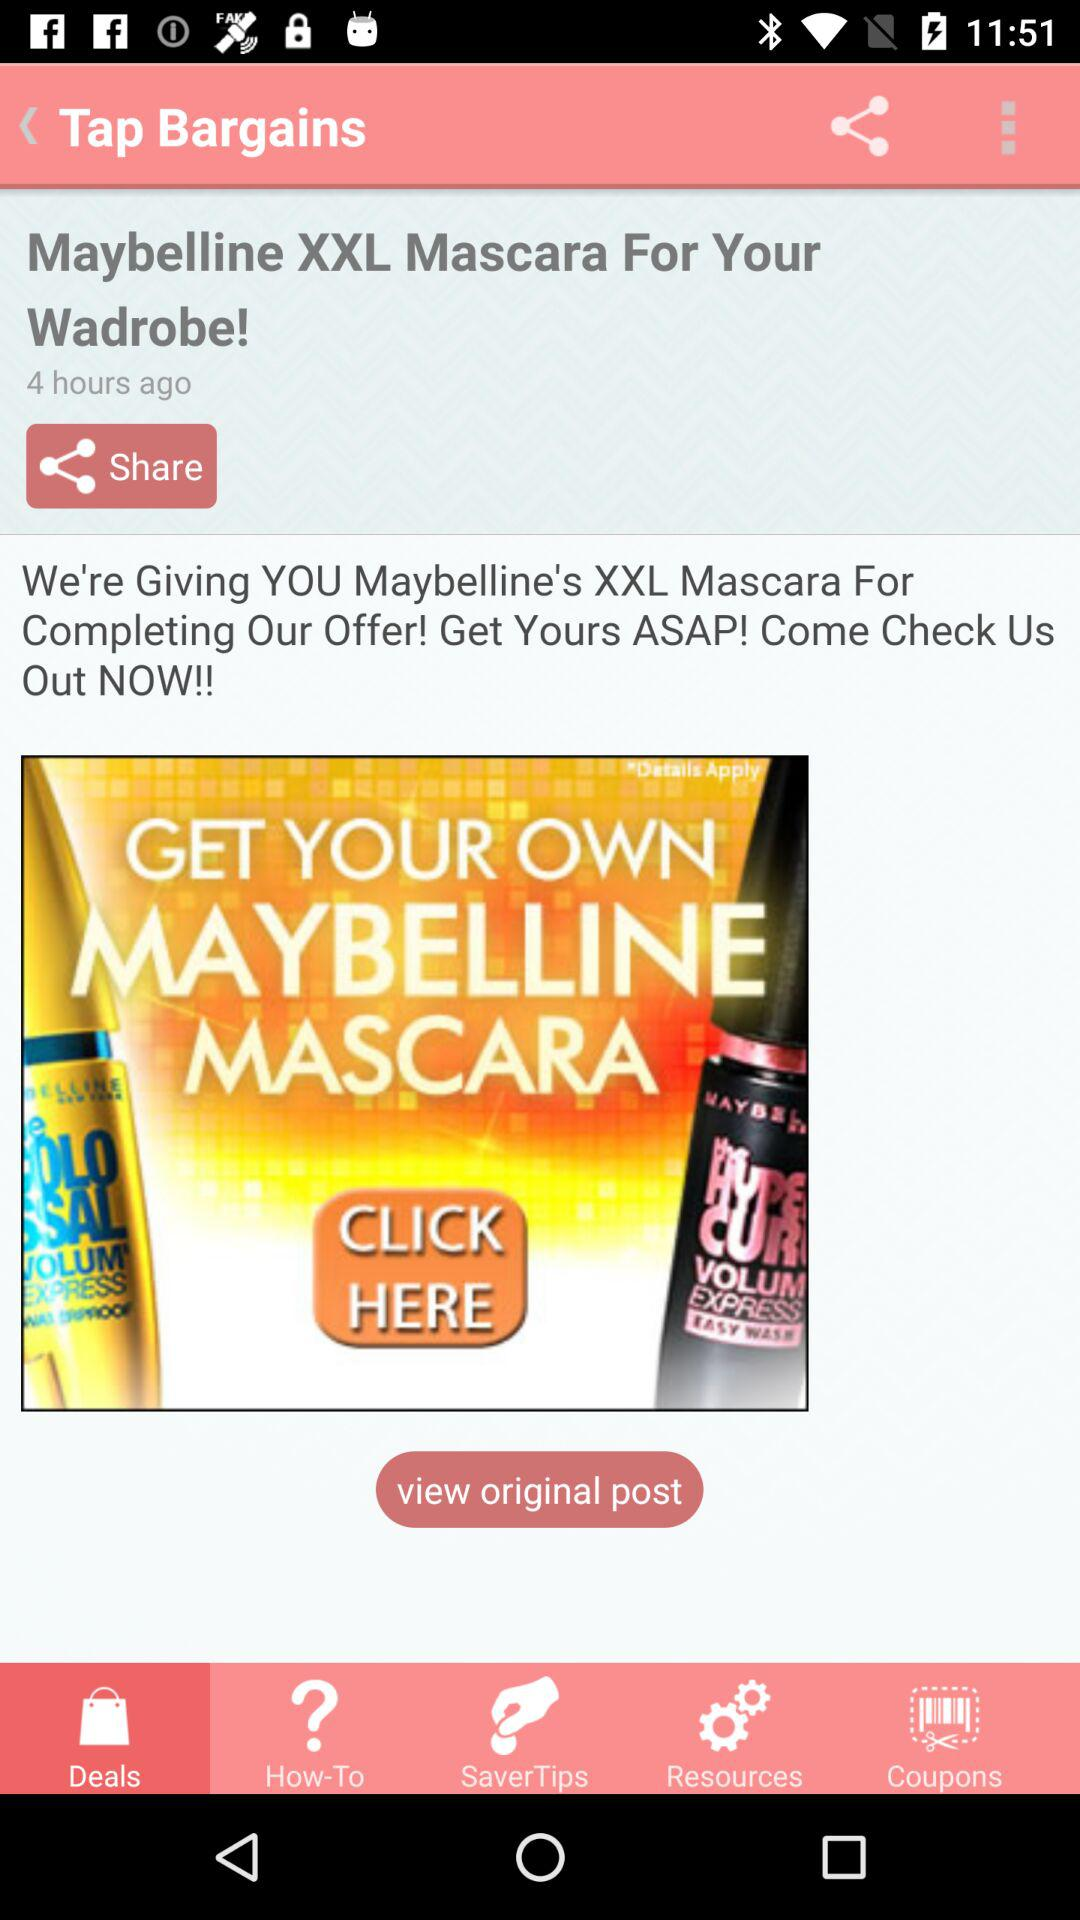What is the app's name? The app's name is "Tap Bargains". 